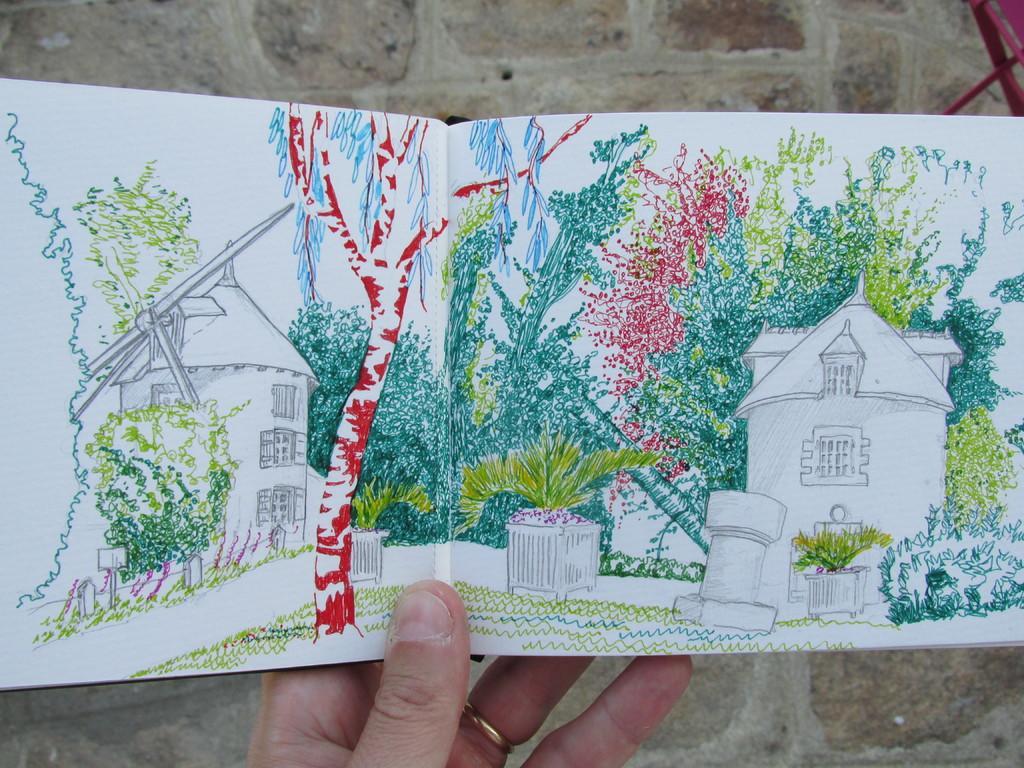In one or two sentences, can you explain what this image depicts? In this image, we can see a hand holding a book contains an art. In the background of the image, we can see a wall. 